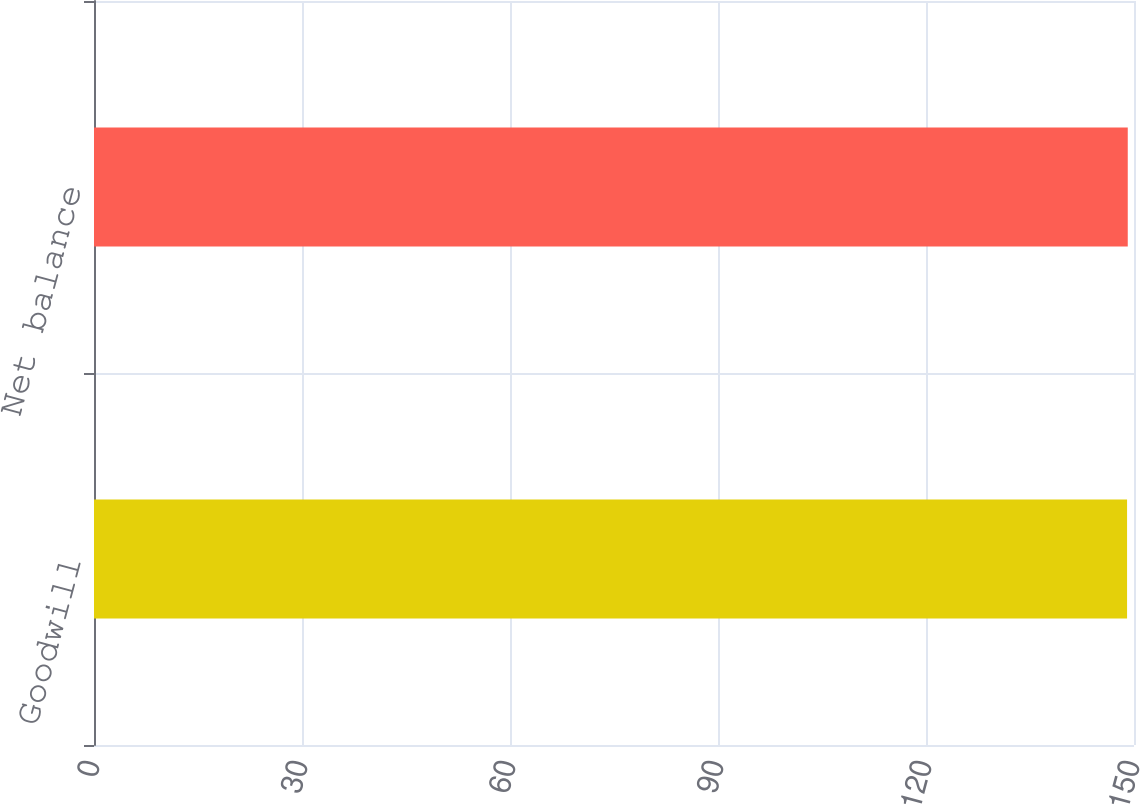Convert chart. <chart><loc_0><loc_0><loc_500><loc_500><bar_chart><fcel>Goodwill<fcel>Net balance<nl><fcel>149<fcel>149.1<nl></chart> 